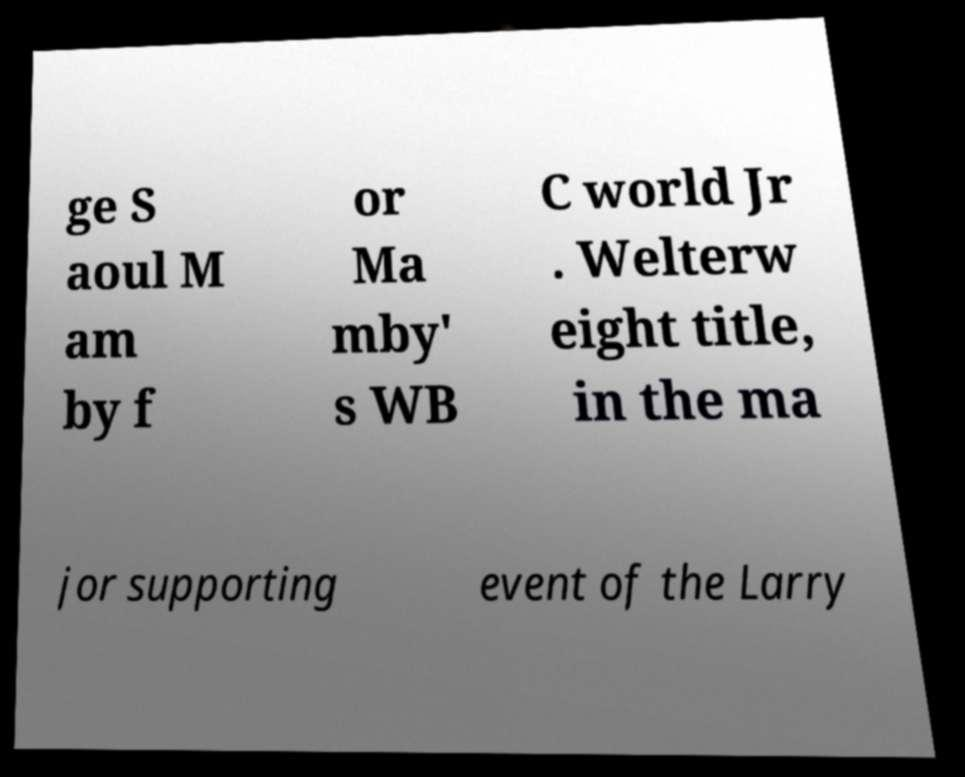I need the written content from this picture converted into text. Can you do that? ge S aoul M am by f or Ma mby' s WB C world Jr . Welterw eight title, in the ma jor supporting event of the Larry 